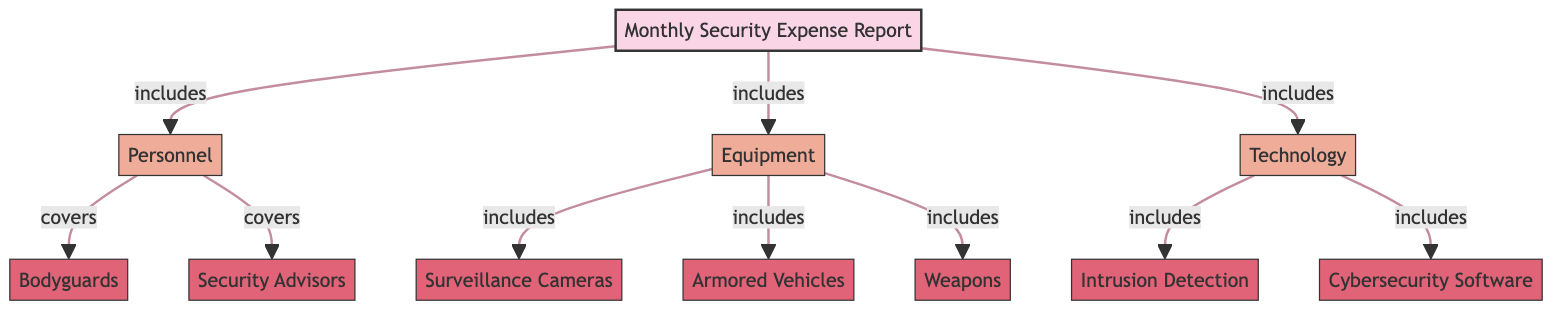What is the main category of the diagram? The diagram starts with a primary node that labels the overall subject, which is "Monthly Security Expense Report." This node signifies the main focus of the diagram, from which other categories branch out.
Answer: Monthly Security Expense Report How many categories are present in the diagram? The diagram shows three main categories: Personnel, Equipment, and Technology. Each of these is directly connected to the main node, indicating they are parts of the overall expense report. Counting these gives us the total number of categories.
Answer: 3 What does the Personnel category cover? Within the Personnel category, there are two subcategories specified: Bodyguards and Security Advisors. This means that these two roles are the main focus of expenses related to personnel as depicted in the diagram.
Answer: Bodyguards, Security Advisors Which subcategory does Equipment include? The Equipment category consists of three subcategories: Surveillance Cameras, Armored Vehicles, and Weapons. These three items represent the various forms of equipment included in the report.
Answer: Surveillance Cameras, Armored Vehicles, Weapons What type of security technology is listed in the diagram? The Technology category in the diagram encompasses two subcategories: Intrusion Detection and Cybersecurity Software. These two elements underline the technological aspects of security expenses.
Answer: Intrusion Detection, Cybersecurity Software How many total subcategories are shown in the diagram? By counting all subcategories across the three main categories in the diagram—two under Personnel, three under Equipment, and two under Technology—we can find the total. The calculation (2 + 3 + 2) results in the total number of subcategories.
Answer: 7 What connects the categories to the main report? The relationship between the main report and the categories is depicted through directional arrows. Each category is directly connected to the main node with an arrow labeled “includes,” indicating their inclusion in the monthly report.
Answer: Includes Which category has the most subcategories? By analyzing the number of subcategories under each main category, Equipment has three subcategories while Personnel has two, and Technology also has two. Therefore, Equipment is the category with the highest number of subcategories in this diagram.
Answer: Equipment 